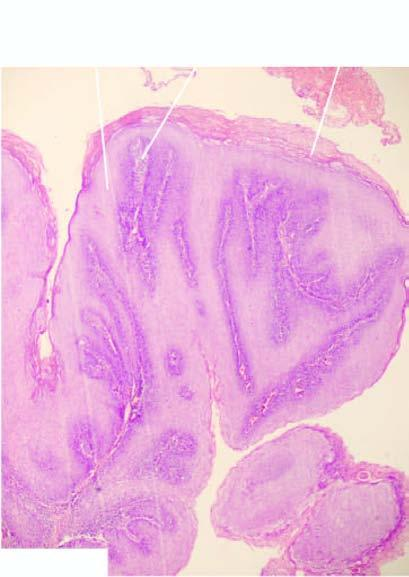re papillae covered with well oriented and orderly layers of squamous cells?
Answer the question using a single word or phrase. Yes 